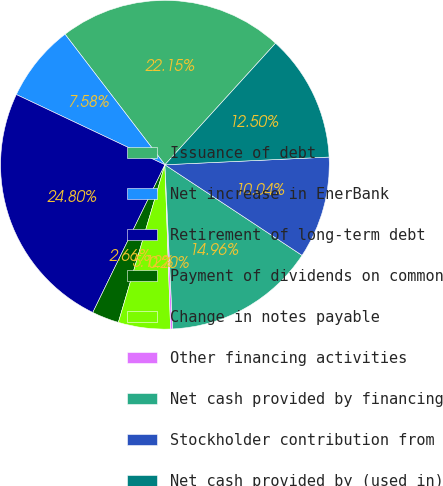<chart> <loc_0><loc_0><loc_500><loc_500><pie_chart><fcel>Issuance of debt<fcel>Net increase in EnerBank<fcel>Retirement of long-term debt<fcel>Payment of dividends on common<fcel>Change in notes payable<fcel>Other financing activities<fcel>Net cash provided by financing<fcel>Stockholder contribution from<fcel>Net cash provided by (used in)<nl><fcel>22.15%<fcel>7.58%<fcel>24.8%<fcel>2.66%<fcel>5.12%<fcel>0.2%<fcel>14.96%<fcel>10.04%<fcel>12.5%<nl></chart> 